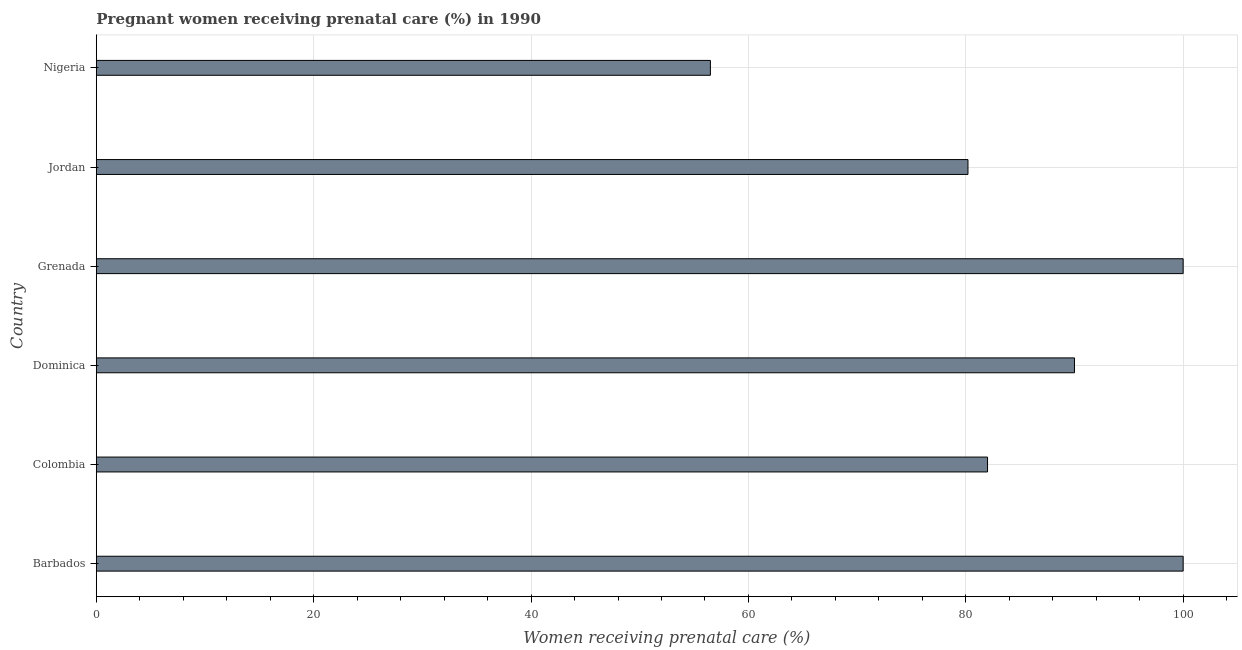Does the graph contain any zero values?
Give a very brief answer. No. Does the graph contain grids?
Your answer should be very brief. Yes. What is the title of the graph?
Ensure brevity in your answer.  Pregnant women receiving prenatal care (%) in 1990. What is the label or title of the X-axis?
Provide a succinct answer. Women receiving prenatal care (%). What is the label or title of the Y-axis?
Give a very brief answer. Country. Across all countries, what is the maximum percentage of pregnant women receiving prenatal care?
Provide a short and direct response. 100. Across all countries, what is the minimum percentage of pregnant women receiving prenatal care?
Offer a terse response. 56.5. In which country was the percentage of pregnant women receiving prenatal care maximum?
Ensure brevity in your answer.  Barbados. In which country was the percentage of pregnant women receiving prenatal care minimum?
Give a very brief answer. Nigeria. What is the sum of the percentage of pregnant women receiving prenatal care?
Make the answer very short. 508.7. What is the difference between the percentage of pregnant women receiving prenatal care in Barbados and Colombia?
Offer a terse response. 18. What is the average percentage of pregnant women receiving prenatal care per country?
Give a very brief answer. 84.78. What is the median percentage of pregnant women receiving prenatal care?
Give a very brief answer. 86. In how many countries, is the percentage of pregnant women receiving prenatal care greater than 44 %?
Your answer should be compact. 6. What is the ratio of the percentage of pregnant women receiving prenatal care in Dominica to that in Nigeria?
Keep it short and to the point. 1.59. Is the difference between the percentage of pregnant women receiving prenatal care in Barbados and Nigeria greater than the difference between any two countries?
Your response must be concise. Yes. Is the sum of the percentage of pregnant women receiving prenatal care in Barbados and Nigeria greater than the maximum percentage of pregnant women receiving prenatal care across all countries?
Offer a terse response. Yes. What is the difference between the highest and the lowest percentage of pregnant women receiving prenatal care?
Offer a terse response. 43.5. In how many countries, is the percentage of pregnant women receiving prenatal care greater than the average percentage of pregnant women receiving prenatal care taken over all countries?
Your answer should be very brief. 3. How many bars are there?
Provide a short and direct response. 6. How many countries are there in the graph?
Offer a terse response. 6. What is the difference between two consecutive major ticks on the X-axis?
Make the answer very short. 20. Are the values on the major ticks of X-axis written in scientific E-notation?
Give a very brief answer. No. What is the Women receiving prenatal care (%) in Barbados?
Give a very brief answer. 100. What is the Women receiving prenatal care (%) of Colombia?
Keep it short and to the point. 82. What is the Women receiving prenatal care (%) in Jordan?
Your answer should be very brief. 80.2. What is the Women receiving prenatal care (%) in Nigeria?
Provide a short and direct response. 56.5. What is the difference between the Women receiving prenatal care (%) in Barbados and Jordan?
Provide a short and direct response. 19.8. What is the difference between the Women receiving prenatal care (%) in Barbados and Nigeria?
Provide a short and direct response. 43.5. What is the difference between the Women receiving prenatal care (%) in Colombia and Jordan?
Provide a succinct answer. 1.8. What is the difference between the Women receiving prenatal care (%) in Colombia and Nigeria?
Your answer should be very brief. 25.5. What is the difference between the Women receiving prenatal care (%) in Dominica and Grenada?
Provide a short and direct response. -10. What is the difference between the Women receiving prenatal care (%) in Dominica and Jordan?
Give a very brief answer. 9.8. What is the difference between the Women receiving prenatal care (%) in Dominica and Nigeria?
Your answer should be compact. 33.5. What is the difference between the Women receiving prenatal care (%) in Grenada and Jordan?
Provide a short and direct response. 19.8. What is the difference between the Women receiving prenatal care (%) in Grenada and Nigeria?
Keep it short and to the point. 43.5. What is the difference between the Women receiving prenatal care (%) in Jordan and Nigeria?
Ensure brevity in your answer.  23.7. What is the ratio of the Women receiving prenatal care (%) in Barbados to that in Colombia?
Your response must be concise. 1.22. What is the ratio of the Women receiving prenatal care (%) in Barbados to that in Dominica?
Provide a succinct answer. 1.11. What is the ratio of the Women receiving prenatal care (%) in Barbados to that in Grenada?
Provide a short and direct response. 1. What is the ratio of the Women receiving prenatal care (%) in Barbados to that in Jordan?
Your answer should be compact. 1.25. What is the ratio of the Women receiving prenatal care (%) in Barbados to that in Nigeria?
Your response must be concise. 1.77. What is the ratio of the Women receiving prenatal care (%) in Colombia to that in Dominica?
Provide a succinct answer. 0.91. What is the ratio of the Women receiving prenatal care (%) in Colombia to that in Grenada?
Offer a very short reply. 0.82. What is the ratio of the Women receiving prenatal care (%) in Colombia to that in Jordan?
Provide a short and direct response. 1.02. What is the ratio of the Women receiving prenatal care (%) in Colombia to that in Nigeria?
Your answer should be very brief. 1.45. What is the ratio of the Women receiving prenatal care (%) in Dominica to that in Jordan?
Provide a succinct answer. 1.12. What is the ratio of the Women receiving prenatal care (%) in Dominica to that in Nigeria?
Your response must be concise. 1.59. What is the ratio of the Women receiving prenatal care (%) in Grenada to that in Jordan?
Offer a very short reply. 1.25. What is the ratio of the Women receiving prenatal care (%) in Grenada to that in Nigeria?
Offer a terse response. 1.77. What is the ratio of the Women receiving prenatal care (%) in Jordan to that in Nigeria?
Your answer should be very brief. 1.42. 